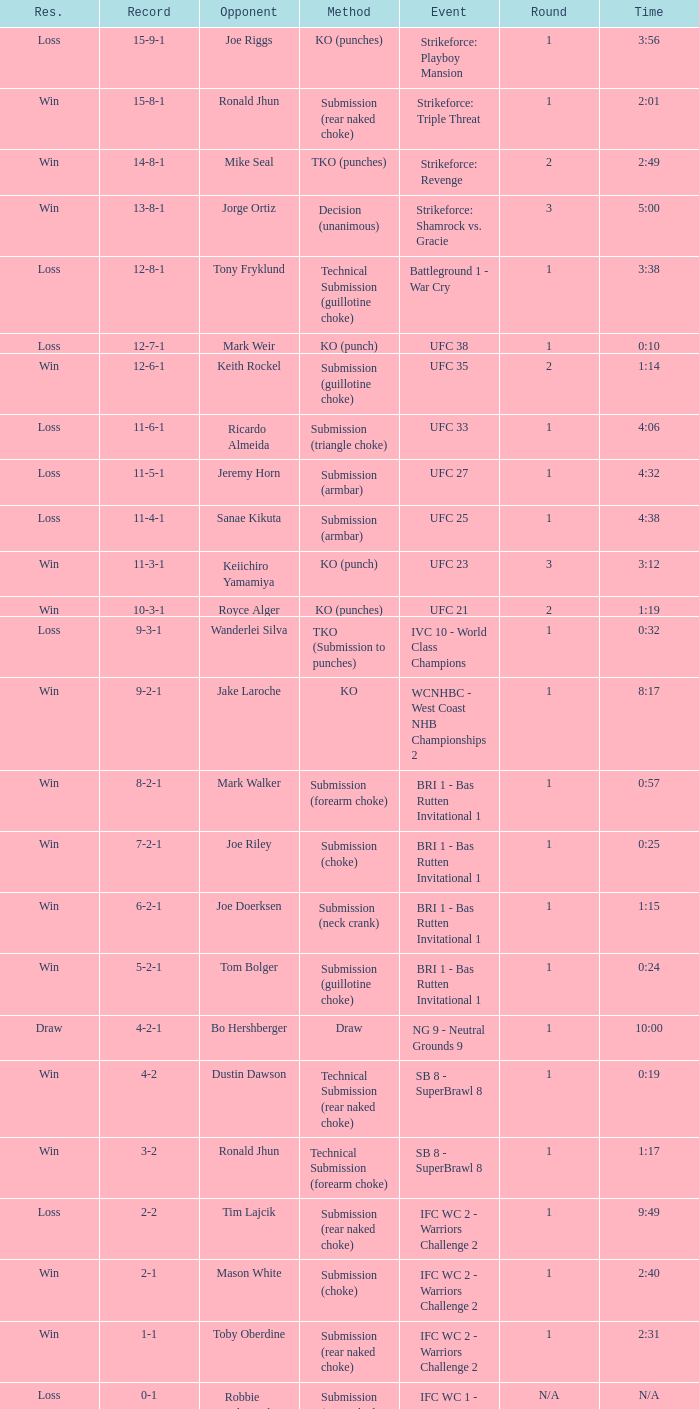What was the record when the method of resolution was KO? 9-2-1. 